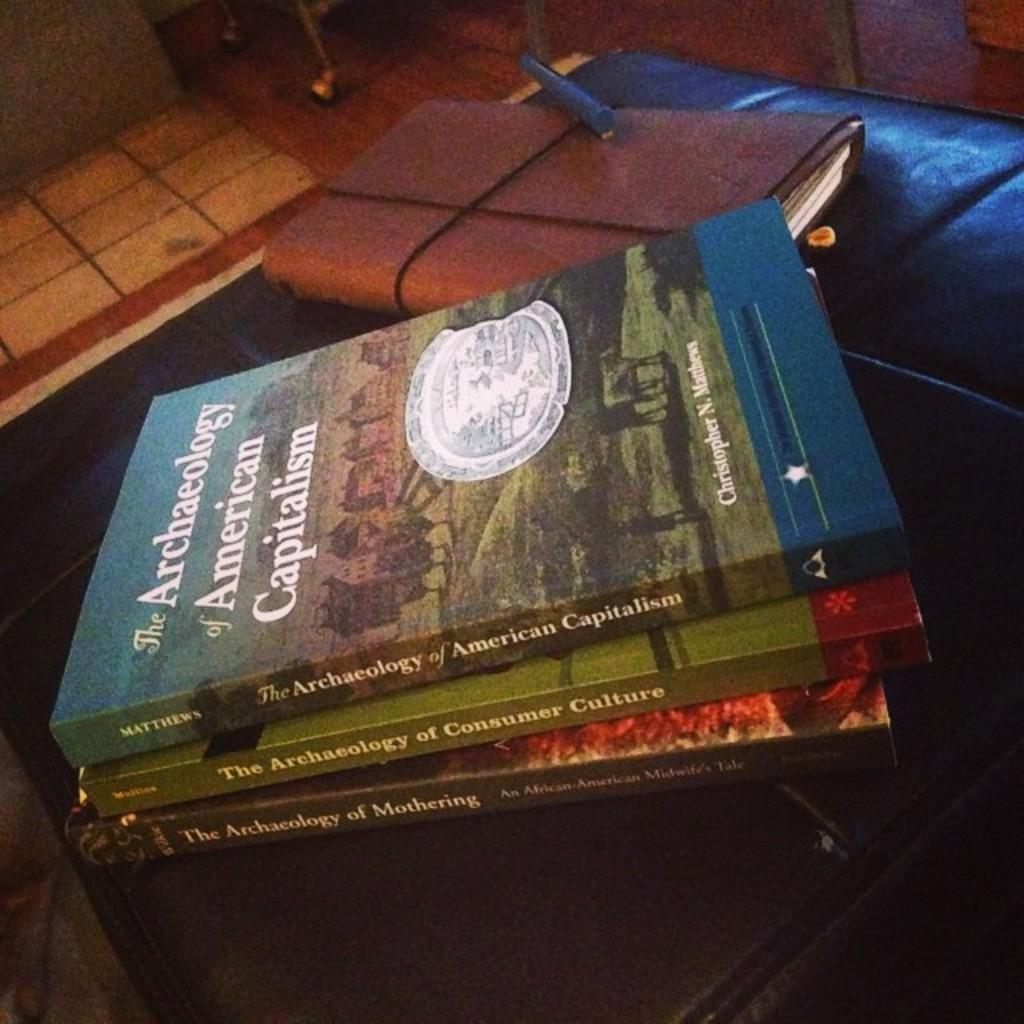<image>
Give a short and clear explanation of the subsequent image. Stack of three paperback books of The Archaeology of American Capitalism 